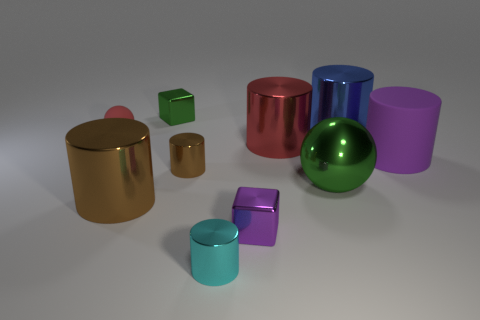Subtract all purple cylinders. How many cylinders are left? 5 Subtract all large blue shiny cylinders. How many cylinders are left? 5 Subtract 3 cylinders. How many cylinders are left? 3 Subtract all gray cylinders. Subtract all cyan spheres. How many cylinders are left? 6 Subtract all cylinders. How many objects are left? 4 Add 8 small brown metallic objects. How many small brown metallic objects exist? 9 Subtract 0 brown balls. How many objects are left? 10 Subtract all big cyan rubber cylinders. Subtract all brown metallic things. How many objects are left? 8 Add 5 small metal blocks. How many small metal blocks are left? 7 